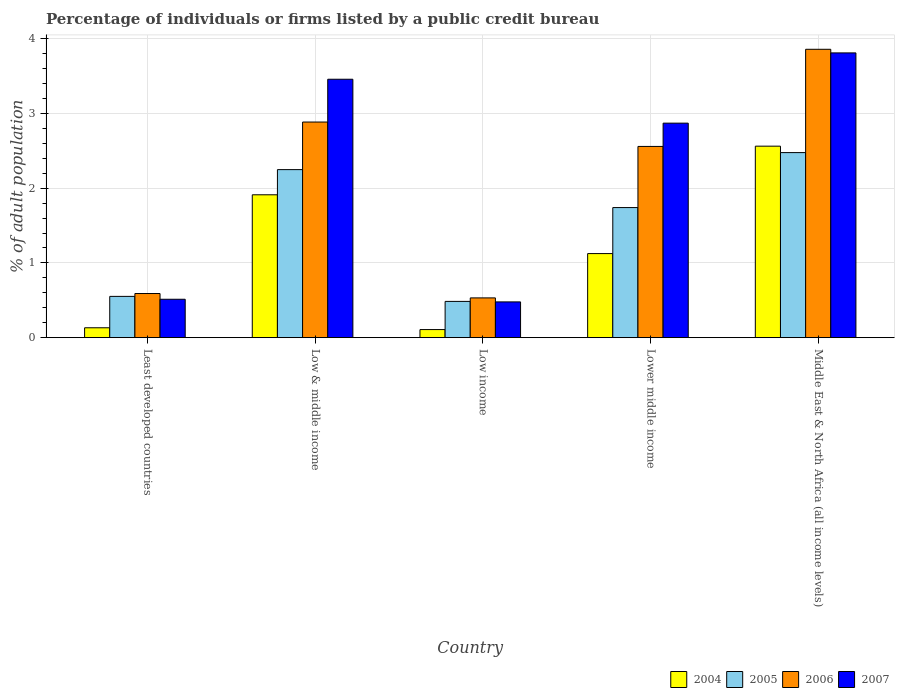How many groups of bars are there?
Your answer should be compact. 5. How many bars are there on the 2nd tick from the right?
Provide a short and direct response. 4. What is the label of the 5th group of bars from the left?
Offer a terse response. Middle East & North Africa (all income levels). In how many cases, is the number of bars for a given country not equal to the number of legend labels?
Provide a succinct answer. 0. What is the percentage of population listed by a public credit bureau in 2007 in Least developed countries?
Ensure brevity in your answer.  0.51. Across all countries, what is the maximum percentage of population listed by a public credit bureau in 2004?
Your answer should be very brief. 2.56. Across all countries, what is the minimum percentage of population listed by a public credit bureau in 2005?
Offer a terse response. 0.49. In which country was the percentage of population listed by a public credit bureau in 2007 maximum?
Offer a very short reply. Middle East & North Africa (all income levels). What is the total percentage of population listed by a public credit bureau in 2006 in the graph?
Offer a very short reply. 10.43. What is the difference between the percentage of population listed by a public credit bureau in 2006 in Least developed countries and that in Low income?
Your response must be concise. 0.06. What is the difference between the percentage of population listed by a public credit bureau in 2007 in Low & middle income and the percentage of population listed by a public credit bureau in 2006 in Low income?
Make the answer very short. 2.93. What is the average percentage of population listed by a public credit bureau in 2004 per country?
Provide a short and direct response. 1.17. What is the difference between the percentage of population listed by a public credit bureau of/in 2004 and percentage of population listed by a public credit bureau of/in 2006 in Low & middle income?
Offer a very short reply. -0.97. In how many countries, is the percentage of population listed by a public credit bureau in 2005 greater than 0.2 %?
Offer a very short reply. 5. What is the ratio of the percentage of population listed by a public credit bureau in 2005 in Least developed countries to that in Lower middle income?
Make the answer very short. 0.32. What is the difference between the highest and the second highest percentage of population listed by a public credit bureau in 2004?
Give a very brief answer. -0.65. What is the difference between the highest and the lowest percentage of population listed by a public credit bureau in 2006?
Make the answer very short. 3.33. In how many countries, is the percentage of population listed by a public credit bureau in 2004 greater than the average percentage of population listed by a public credit bureau in 2004 taken over all countries?
Offer a terse response. 2. Is the sum of the percentage of population listed by a public credit bureau in 2005 in Low & middle income and Middle East & North Africa (all income levels) greater than the maximum percentage of population listed by a public credit bureau in 2007 across all countries?
Your answer should be compact. Yes. Is it the case that in every country, the sum of the percentage of population listed by a public credit bureau in 2007 and percentage of population listed by a public credit bureau in 2004 is greater than the sum of percentage of population listed by a public credit bureau in 2006 and percentage of population listed by a public credit bureau in 2005?
Make the answer very short. No. What does the 4th bar from the right in Low income represents?
Your response must be concise. 2004. Is it the case that in every country, the sum of the percentage of population listed by a public credit bureau in 2006 and percentage of population listed by a public credit bureau in 2004 is greater than the percentage of population listed by a public credit bureau in 2007?
Give a very brief answer. Yes. What is the title of the graph?
Ensure brevity in your answer.  Percentage of individuals or firms listed by a public credit bureau. Does "2007" appear as one of the legend labels in the graph?
Make the answer very short. Yes. What is the label or title of the Y-axis?
Your answer should be very brief. % of adult population. What is the % of adult population of 2004 in Least developed countries?
Ensure brevity in your answer.  0.13. What is the % of adult population in 2005 in Least developed countries?
Offer a very short reply. 0.55. What is the % of adult population in 2006 in Least developed countries?
Your answer should be very brief. 0.59. What is the % of adult population of 2007 in Least developed countries?
Offer a terse response. 0.51. What is the % of adult population of 2004 in Low & middle income?
Keep it short and to the point. 1.91. What is the % of adult population of 2005 in Low & middle income?
Provide a short and direct response. 2.25. What is the % of adult population of 2006 in Low & middle income?
Make the answer very short. 2.89. What is the % of adult population of 2007 in Low & middle income?
Your answer should be very brief. 3.46. What is the % of adult population of 2004 in Low income?
Keep it short and to the point. 0.11. What is the % of adult population in 2005 in Low income?
Offer a very short reply. 0.49. What is the % of adult population in 2006 in Low income?
Your response must be concise. 0.53. What is the % of adult population in 2007 in Low income?
Provide a succinct answer. 0.48. What is the % of adult population of 2004 in Lower middle income?
Your answer should be compact. 1.12. What is the % of adult population of 2005 in Lower middle income?
Ensure brevity in your answer.  1.74. What is the % of adult population of 2006 in Lower middle income?
Offer a terse response. 2.56. What is the % of adult population of 2007 in Lower middle income?
Provide a short and direct response. 2.87. What is the % of adult population in 2004 in Middle East & North Africa (all income levels)?
Your answer should be compact. 2.56. What is the % of adult population in 2005 in Middle East & North Africa (all income levels)?
Make the answer very short. 2.48. What is the % of adult population in 2006 in Middle East & North Africa (all income levels)?
Your answer should be very brief. 3.86. What is the % of adult population in 2007 in Middle East & North Africa (all income levels)?
Keep it short and to the point. 3.81. Across all countries, what is the maximum % of adult population of 2004?
Offer a very short reply. 2.56. Across all countries, what is the maximum % of adult population of 2005?
Provide a short and direct response. 2.48. Across all countries, what is the maximum % of adult population in 2006?
Provide a succinct answer. 3.86. Across all countries, what is the maximum % of adult population in 2007?
Offer a terse response. 3.81. Across all countries, what is the minimum % of adult population of 2004?
Provide a short and direct response. 0.11. Across all countries, what is the minimum % of adult population in 2005?
Offer a very short reply. 0.49. Across all countries, what is the minimum % of adult population of 2006?
Give a very brief answer. 0.53. Across all countries, what is the minimum % of adult population of 2007?
Offer a very short reply. 0.48. What is the total % of adult population in 2004 in the graph?
Make the answer very short. 5.84. What is the total % of adult population in 2005 in the graph?
Provide a short and direct response. 7.5. What is the total % of adult population in 2006 in the graph?
Your response must be concise. 10.43. What is the total % of adult population of 2007 in the graph?
Provide a succinct answer. 11.13. What is the difference between the % of adult population in 2004 in Least developed countries and that in Low & middle income?
Your answer should be compact. -1.78. What is the difference between the % of adult population in 2005 in Least developed countries and that in Low & middle income?
Your response must be concise. -1.7. What is the difference between the % of adult population in 2006 in Least developed countries and that in Low & middle income?
Your answer should be very brief. -2.29. What is the difference between the % of adult population in 2007 in Least developed countries and that in Low & middle income?
Keep it short and to the point. -2.94. What is the difference between the % of adult population of 2004 in Least developed countries and that in Low income?
Keep it short and to the point. 0.02. What is the difference between the % of adult population of 2005 in Least developed countries and that in Low income?
Make the answer very short. 0.07. What is the difference between the % of adult population of 2006 in Least developed countries and that in Low income?
Provide a short and direct response. 0.06. What is the difference between the % of adult population in 2007 in Least developed countries and that in Low income?
Ensure brevity in your answer.  0.04. What is the difference between the % of adult population in 2004 in Least developed countries and that in Lower middle income?
Provide a succinct answer. -0.99. What is the difference between the % of adult population of 2005 in Least developed countries and that in Lower middle income?
Give a very brief answer. -1.19. What is the difference between the % of adult population in 2006 in Least developed countries and that in Lower middle income?
Offer a terse response. -1.97. What is the difference between the % of adult population of 2007 in Least developed countries and that in Lower middle income?
Your answer should be very brief. -2.36. What is the difference between the % of adult population in 2004 in Least developed countries and that in Middle East & North Africa (all income levels)?
Keep it short and to the point. -2.43. What is the difference between the % of adult population of 2005 in Least developed countries and that in Middle East & North Africa (all income levels)?
Offer a very short reply. -1.92. What is the difference between the % of adult population of 2006 in Least developed countries and that in Middle East & North Africa (all income levels)?
Give a very brief answer. -3.27. What is the difference between the % of adult population of 2007 in Least developed countries and that in Middle East & North Africa (all income levels)?
Your answer should be compact. -3.3. What is the difference between the % of adult population in 2004 in Low & middle income and that in Low income?
Keep it short and to the point. 1.8. What is the difference between the % of adult population in 2005 in Low & middle income and that in Low income?
Provide a succinct answer. 1.76. What is the difference between the % of adult population in 2006 in Low & middle income and that in Low income?
Your answer should be compact. 2.35. What is the difference between the % of adult population in 2007 in Low & middle income and that in Low income?
Your answer should be compact. 2.98. What is the difference between the % of adult population in 2004 in Low & middle income and that in Lower middle income?
Your answer should be compact. 0.79. What is the difference between the % of adult population of 2005 in Low & middle income and that in Lower middle income?
Your answer should be compact. 0.51. What is the difference between the % of adult population of 2006 in Low & middle income and that in Lower middle income?
Give a very brief answer. 0.33. What is the difference between the % of adult population in 2007 in Low & middle income and that in Lower middle income?
Your response must be concise. 0.59. What is the difference between the % of adult population of 2004 in Low & middle income and that in Middle East & North Africa (all income levels)?
Offer a terse response. -0.65. What is the difference between the % of adult population in 2005 in Low & middle income and that in Middle East & North Africa (all income levels)?
Ensure brevity in your answer.  -0.23. What is the difference between the % of adult population in 2006 in Low & middle income and that in Middle East & North Africa (all income levels)?
Your answer should be compact. -0.97. What is the difference between the % of adult population of 2007 in Low & middle income and that in Middle East & North Africa (all income levels)?
Offer a terse response. -0.35. What is the difference between the % of adult population in 2004 in Low income and that in Lower middle income?
Make the answer very short. -1.02. What is the difference between the % of adult population in 2005 in Low income and that in Lower middle income?
Provide a succinct answer. -1.26. What is the difference between the % of adult population in 2006 in Low income and that in Lower middle income?
Make the answer very short. -2.03. What is the difference between the % of adult population in 2007 in Low income and that in Lower middle income?
Provide a succinct answer. -2.39. What is the difference between the % of adult population in 2004 in Low income and that in Middle East & North Africa (all income levels)?
Your answer should be compact. -2.45. What is the difference between the % of adult population in 2005 in Low income and that in Middle East & North Africa (all income levels)?
Your response must be concise. -1.99. What is the difference between the % of adult population in 2006 in Low income and that in Middle East & North Africa (all income levels)?
Offer a terse response. -3.33. What is the difference between the % of adult population of 2007 in Low income and that in Middle East & North Africa (all income levels)?
Offer a very short reply. -3.33. What is the difference between the % of adult population of 2004 in Lower middle income and that in Middle East & North Africa (all income levels)?
Provide a short and direct response. -1.44. What is the difference between the % of adult population of 2005 in Lower middle income and that in Middle East & North Africa (all income levels)?
Offer a terse response. -0.74. What is the difference between the % of adult population in 2006 in Lower middle income and that in Middle East & North Africa (all income levels)?
Give a very brief answer. -1.3. What is the difference between the % of adult population in 2007 in Lower middle income and that in Middle East & North Africa (all income levels)?
Give a very brief answer. -0.94. What is the difference between the % of adult population of 2004 in Least developed countries and the % of adult population of 2005 in Low & middle income?
Give a very brief answer. -2.12. What is the difference between the % of adult population of 2004 in Least developed countries and the % of adult population of 2006 in Low & middle income?
Your response must be concise. -2.75. What is the difference between the % of adult population in 2004 in Least developed countries and the % of adult population in 2007 in Low & middle income?
Provide a succinct answer. -3.33. What is the difference between the % of adult population in 2005 in Least developed countries and the % of adult population in 2006 in Low & middle income?
Make the answer very short. -2.33. What is the difference between the % of adult population in 2005 in Least developed countries and the % of adult population in 2007 in Low & middle income?
Offer a very short reply. -2.91. What is the difference between the % of adult population in 2006 in Least developed countries and the % of adult population in 2007 in Low & middle income?
Keep it short and to the point. -2.87. What is the difference between the % of adult population of 2004 in Least developed countries and the % of adult population of 2005 in Low income?
Offer a terse response. -0.35. What is the difference between the % of adult population of 2004 in Least developed countries and the % of adult population of 2006 in Low income?
Offer a very short reply. -0.4. What is the difference between the % of adult population in 2004 in Least developed countries and the % of adult population in 2007 in Low income?
Provide a short and direct response. -0.35. What is the difference between the % of adult population in 2005 in Least developed countries and the % of adult population in 2006 in Low income?
Provide a short and direct response. 0.02. What is the difference between the % of adult population in 2005 in Least developed countries and the % of adult population in 2007 in Low income?
Provide a succinct answer. 0.07. What is the difference between the % of adult population of 2006 in Least developed countries and the % of adult population of 2007 in Low income?
Make the answer very short. 0.11. What is the difference between the % of adult population of 2004 in Least developed countries and the % of adult population of 2005 in Lower middle income?
Your answer should be compact. -1.61. What is the difference between the % of adult population of 2004 in Least developed countries and the % of adult population of 2006 in Lower middle income?
Keep it short and to the point. -2.43. What is the difference between the % of adult population in 2004 in Least developed countries and the % of adult population in 2007 in Lower middle income?
Provide a short and direct response. -2.74. What is the difference between the % of adult population of 2005 in Least developed countries and the % of adult population of 2006 in Lower middle income?
Your response must be concise. -2.01. What is the difference between the % of adult population in 2005 in Least developed countries and the % of adult population in 2007 in Lower middle income?
Keep it short and to the point. -2.32. What is the difference between the % of adult population of 2006 in Least developed countries and the % of adult population of 2007 in Lower middle income?
Make the answer very short. -2.28. What is the difference between the % of adult population in 2004 in Least developed countries and the % of adult population in 2005 in Middle East & North Africa (all income levels)?
Your answer should be very brief. -2.34. What is the difference between the % of adult population of 2004 in Least developed countries and the % of adult population of 2006 in Middle East & North Africa (all income levels)?
Offer a very short reply. -3.73. What is the difference between the % of adult population in 2004 in Least developed countries and the % of adult population in 2007 in Middle East & North Africa (all income levels)?
Give a very brief answer. -3.68. What is the difference between the % of adult population of 2005 in Least developed countries and the % of adult population of 2006 in Middle East & North Africa (all income levels)?
Your answer should be very brief. -3.31. What is the difference between the % of adult population in 2005 in Least developed countries and the % of adult population in 2007 in Middle East & North Africa (all income levels)?
Provide a succinct answer. -3.26. What is the difference between the % of adult population in 2006 in Least developed countries and the % of adult population in 2007 in Middle East & North Africa (all income levels)?
Ensure brevity in your answer.  -3.22. What is the difference between the % of adult population of 2004 in Low & middle income and the % of adult population of 2005 in Low income?
Give a very brief answer. 1.43. What is the difference between the % of adult population of 2004 in Low & middle income and the % of adult population of 2006 in Low income?
Give a very brief answer. 1.38. What is the difference between the % of adult population of 2004 in Low & middle income and the % of adult population of 2007 in Low income?
Make the answer very short. 1.43. What is the difference between the % of adult population of 2005 in Low & middle income and the % of adult population of 2006 in Low income?
Your answer should be compact. 1.72. What is the difference between the % of adult population of 2005 in Low & middle income and the % of adult population of 2007 in Low income?
Give a very brief answer. 1.77. What is the difference between the % of adult population in 2006 in Low & middle income and the % of adult population in 2007 in Low income?
Offer a terse response. 2.41. What is the difference between the % of adult population in 2004 in Low & middle income and the % of adult population in 2005 in Lower middle income?
Your response must be concise. 0.17. What is the difference between the % of adult population in 2004 in Low & middle income and the % of adult population in 2006 in Lower middle income?
Provide a short and direct response. -0.65. What is the difference between the % of adult population in 2004 in Low & middle income and the % of adult population in 2007 in Lower middle income?
Provide a short and direct response. -0.96. What is the difference between the % of adult population in 2005 in Low & middle income and the % of adult population in 2006 in Lower middle income?
Your response must be concise. -0.31. What is the difference between the % of adult population of 2005 in Low & middle income and the % of adult population of 2007 in Lower middle income?
Provide a short and direct response. -0.62. What is the difference between the % of adult population in 2006 in Low & middle income and the % of adult population in 2007 in Lower middle income?
Your answer should be very brief. 0.01. What is the difference between the % of adult population in 2004 in Low & middle income and the % of adult population in 2005 in Middle East & North Africa (all income levels)?
Provide a short and direct response. -0.56. What is the difference between the % of adult population in 2004 in Low & middle income and the % of adult population in 2006 in Middle East & North Africa (all income levels)?
Offer a very short reply. -1.95. What is the difference between the % of adult population in 2004 in Low & middle income and the % of adult population in 2007 in Middle East & North Africa (all income levels)?
Give a very brief answer. -1.9. What is the difference between the % of adult population in 2005 in Low & middle income and the % of adult population in 2006 in Middle East & North Africa (all income levels)?
Ensure brevity in your answer.  -1.61. What is the difference between the % of adult population of 2005 in Low & middle income and the % of adult population of 2007 in Middle East & North Africa (all income levels)?
Provide a succinct answer. -1.56. What is the difference between the % of adult population of 2006 in Low & middle income and the % of adult population of 2007 in Middle East & North Africa (all income levels)?
Keep it short and to the point. -0.93. What is the difference between the % of adult population of 2004 in Low income and the % of adult population of 2005 in Lower middle income?
Provide a short and direct response. -1.63. What is the difference between the % of adult population in 2004 in Low income and the % of adult population in 2006 in Lower middle income?
Ensure brevity in your answer.  -2.45. What is the difference between the % of adult population of 2004 in Low income and the % of adult population of 2007 in Lower middle income?
Offer a terse response. -2.76. What is the difference between the % of adult population in 2005 in Low income and the % of adult population in 2006 in Lower middle income?
Give a very brief answer. -2.07. What is the difference between the % of adult population in 2005 in Low income and the % of adult population in 2007 in Lower middle income?
Your answer should be compact. -2.39. What is the difference between the % of adult population in 2006 in Low income and the % of adult population in 2007 in Lower middle income?
Keep it short and to the point. -2.34. What is the difference between the % of adult population in 2004 in Low income and the % of adult population in 2005 in Middle East & North Africa (all income levels)?
Make the answer very short. -2.37. What is the difference between the % of adult population in 2004 in Low income and the % of adult population in 2006 in Middle East & North Africa (all income levels)?
Make the answer very short. -3.75. What is the difference between the % of adult population of 2004 in Low income and the % of adult population of 2007 in Middle East & North Africa (all income levels)?
Make the answer very short. -3.7. What is the difference between the % of adult population of 2005 in Low income and the % of adult population of 2006 in Middle East & North Africa (all income levels)?
Provide a short and direct response. -3.37. What is the difference between the % of adult population in 2005 in Low income and the % of adult population in 2007 in Middle East & North Africa (all income levels)?
Offer a very short reply. -3.33. What is the difference between the % of adult population of 2006 in Low income and the % of adult population of 2007 in Middle East & North Africa (all income levels)?
Provide a short and direct response. -3.28. What is the difference between the % of adult population in 2004 in Lower middle income and the % of adult population in 2005 in Middle East & North Africa (all income levels)?
Keep it short and to the point. -1.35. What is the difference between the % of adult population of 2004 in Lower middle income and the % of adult population of 2006 in Middle East & North Africa (all income levels)?
Make the answer very short. -2.73. What is the difference between the % of adult population in 2004 in Lower middle income and the % of adult population in 2007 in Middle East & North Africa (all income levels)?
Offer a very short reply. -2.69. What is the difference between the % of adult population in 2005 in Lower middle income and the % of adult population in 2006 in Middle East & North Africa (all income levels)?
Your answer should be compact. -2.12. What is the difference between the % of adult population in 2005 in Lower middle income and the % of adult population in 2007 in Middle East & North Africa (all income levels)?
Give a very brief answer. -2.07. What is the difference between the % of adult population of 2006 in Lower middle income and the % of adult population of 2007 in Middle East & North Africa (all income levels)?
Your answer should be very brief. -1.25. What is the average % of adult population in 2004 per country?
Give a very brief answer. 1.17. What is the average % of adult population in 2005 per country?
Make the answer very short. 1.5. What is the average % of adult population of 2006 per country?
Give a very brief answer. 2.09. What is the average % of adult population in 2007 per country?
Give a very brief answer. 2.23. What is the difference between the % of adult population of 2004 and % of adult population of 2005 in Least developed countries?
Provide a succinct answer. -0.42. What is the difference between the % of adult population of 2004 and % of adult population of 2006 in Least developed countries?
Ensure brevity in your answer.  -0.46. What is the difference between the % of adult population in 2004 and % of adult population in 2007 in Least developed countries?
Give a very brief answer. -0.38. What is the difference between the % of adult population in 2005 and % of adult population in 2006 in Least developed countries?
Make the answer very short. -0.04. What is the difference between the % of adult population in 2005 and % of adult population in 2007 in Least developed countries?
Make the answer very short. 0.04. What is the difference between the % of adult population of 2006 and % of adult population of 2007 in Least developed countries?
Your response must be concise. 0.08. What is the difference between the % of adult population in 2004 and % of adult population in 2005 in Low & middle income?
Your response must be concise. -0.34. What is the difference between the % of adult population in 2004 and % of adult population in 2006 in Low & middle income?
Keep it short and to the point. -0.97. What is the difference between the % of adult population of 2004 and % of adult population of 2007 in Low & middle income?
Give a very brief answer. -1.55. What is the difference between the % of adult population of 2005 and % of adult population of 2006 in Low & middle income?
Ensure brevity in your answer.  -0.64. What is the difference between the % of adult population in 2005 and % of adult population in 2007 in Low & middle income?
Your answer should be compact. -1.21. What is the difference between the % of adult population of 2006 and % of adult population of 2007 in Low & middle income?
Your response must be concise. -0.57. What is the difference between the % of adult population of 2004 and % of adult population of 2005 in Low income?
Offer a terse response. -0.38. What is the difference between the % of adult population of 2004 and % of adult population of 2006 in Low income?
Ensure brevity in your answer.  -0.42. What is the difference between the % of adult population of 2004 and % of adult population of 2007 in Low income?
Give a very brief answer. -0.37. What is the difference between the % of adult population in 2005 and % of adult population in 2006 in Low income?
Ensure brevity in your answer.  -0.05. What is the difference between the % of adult population in 2005 and % of adult population in 2007 in Low income?
Offer a very short reply. 0.01. What is the difference between the % of adult population in 2006 and % of adult population in 2007 in Low income?
Offer a very short reply. 0.05. What is the difference between the % of adult population of 2004 and % of adult population of 2005 in Lower middle income?
Your response must be concise. -0.62. What is the difference between the % of adult population in 2004 and % of adult population in 2006 in Lower middle income?
Your answer should be very brief. -1.43. What is the difference between the % of adult population of 2004 and % of adult population of 2007 in Lower middle income?
Ensure brevity in your answer.  -1.75. What is the difference between the % of adult population in 2005 and % of adult population in 2006 in Lower middle income?
Offer a terse response. -0.82. What is the difference between the % of adult population of 2005 and % of adult population of 2007 in Lower middle income?
Keep it short and to the point. -1.13. What is the difference between the % of adult population of 2006 and % of adult population of 2007 in Lower middle income?
Offer a terse response. -0.31. What is the difference between the % of adult population of 2004 and % of adult population of 2005 in Middle East & North Africa (all income levels)?
Give a very brief answer. 0.09. What is the difference between the % of adult population in 2004 and % of adult population in 2006 in Middle East & North Africa (all income levels)?
Your response must be concise. -1.3. What is the difference between the % of adult population in 2004 and % of adult population in 2007 in Middle East & North Africa (all income levels)?
Offer a very short reply. -1.25. What is the difference between the % of adult population in 2005 and % of adult population in 2006 in Middle East & North Africa (all income levels)?
Make the answer very short. -1.38. What is the difference between the % of adult population of 2005 and % of adult population of 2007 in Middle East & North Africa (all income levels)?
Provide a succinct answer. -1.33. What is the difference between the % of adult population in 2006 and % of adult population in 2007 in Middle East & North Africa (all income levels)?
Make the answer very short. 0.05. What is the ratio of the % of adult population of 2004 in Least developed countries to that in Low & middle income?
Provide a succinct answer. 0.07. What is the ratio of the % of adult population in 2005 in Least developed countries to that in Low & middle income?
Keep it short and to the point. 0.25. What is the ratio of the % of adult population in 2006 in Least developed countries to that in Low & middle income?
Keep it short and to the point. 0.2. What is the ratio of the % of adult population in 2007 in Least developed countries to that in Low & middle income?
Your answer should be very brief. 0.15. What is the ratio of the % of adult population of 2004 in Least developed countries to that in Low income?
Give a very brief answer. 1.22. What is the ratio of the % of adult population in 2005 in Least developed countries to that in Low income?
Your answer should be compact. 1.14. What is the ratio of the % of adult population in 2006 in Least developed countries to that in Low income?
Make the answer very short. 1.11. What is the ratio of the % of adult population of 2007 in Least developed countries to that in Low income?
Provide a succinct answer. 1.07. What is the ratio of the % of adult population of 2004 in Least developed countries to that in Lower middle income?
Offer a terse response. 0.12. What is the ratio of the % of adult population of 2005 in Least developed countries to that in Lower middle income?
Keep it short and to the point. 0.32. What is the ratio of the % of adult population of 2006 in Least developed countries to that in Lower middle income?
Give a very brief answer. 0.23. What is the ratio of the % of adult population of 2007 in Least developed countries to that in Lower middle income?
Keep it short and to the point. 0.18. What is the ratio of the % of adult population in 2004 in Least developed countries to that in Middle East & North Africa (all income levels)?
Provide a short and direct response. 0.05. What is the ratio of the % of adult population of 2005 in Least developed countries to that in Middle East & North Africa (all income levels)?
Offer a very short reply. 0.22. What is the ratio of the % of adult population of 2006 in Least developed countries to that in Middle East & North Africa (all income levels)?
Provide a short and direct response. 0.15. What is the ratio of the % of adult population of 2007 in Least developed countries to that in Middle East & North Africa (all income levels)?
Your response must be concise. 0.13. What is the ratio of the % of adult population in 2004 in Low & middle income to that in Low income?
Your answer should be very brief. 17.65. What is the ratio of the % of adult population of 2005 in Low & middle income to that in Low income?
Ensure brevity in your answer.  4.63. What is the ratio of the % of adult population in 2006 in Low & middle income to that in Low income?
Provide a succinct answer. 5.42. What is the ratio of the % of adult population of 2007 in Low & middle income to that in Low income?
Give a very brief answer. 7.23. What is the ratio of the % of adult population of 2004 in Low & middle income to that in Lower middle income?
Offer a terse response. 1.7. What is the ratio of the % of adult population of 2005 in Low & middle income to that in Lower middle income?
Provide a short and direct response. 1.29. What is the ratio of the % of adult population of 2006 in Low & middle income to that in Lower middle income?
Give a very brief answer. 1.13. What is the ratio of the % of adult population in 2007 in Low & middle income to that in Lower middle income?
Your answer should be very brief. 1.2. What is the ratio of the % of adult population of 2004 in Low & middle income to that in Middle East & North Africa (all income levels)?
Provide a short and direct response. 0.75. What is the ratio of the % of adult population of 2005 in Low & middle income to that in Middle East & North Africa (all income levels)?
Your response must be concise. 0.91. What is the ratio of the % of adult population in 2006 in Low & middle income to that in Middle East & North Africa (all income levels)?
Give a very brief answer. 0.75. What is the ratio of the % of adult population in 2007 in Low & middle income to that in Middle East & North Africa (all income levels)?
Offer a terse response. 0.91. What is the ratio of the % of adult population in 2004 in Low income to that in Lower middle income?
Give a very brief answer. 0.1. What is the ratio of the % of adult population in 2005 in Low income to that in Lower middle income?
Provide a short and direct response. 0.28. What is the ratio of the % of adult population of 2006 in Low income to that in Lower middle income?
Your answer should be compact. 0.21. What is the ratio of the % of adult population in 2004 in Low income to that in Middle East & North Africa (all income levels)?
Keep it short and to the point. 0.04. What is the ratio of the % of adult population in 2005 in Low income to that in Middle East & North Africa (all income levels)?
Keep it short and to the point. 0.2. What is the ratio of the % of adult population in 2006 in Low income to that in Middle East & North Africa (all income levels)?
Your response must be concise. 0.14. What is the ratio of the % of adult population in 2007 in Low income to that in Middle East & North Africa (all income levels)?
Your response must be concise. 0.13. What is the ratio of the % of adult population of 2004 in Lower middle income to that in Middle East & North Africa (all income levels)?
Provide a short and direct response. 0.44. What is the ratio of the % of adult population of 2005 in Lower middle income to that in Middle East & North Africa (all income levels)?
Your answer should be very brief. 0.7. What is the ratio of the % of adult population of 2006 in Lower middle income to that in Middle East & North Africa (all income levels)?
Give a very brief answer. 0.66. What is the ratio of the % of adult population in 2007 in Lower middle income to that in Middle East & North Africa (all income levels)?
Provide a short and direct response. 0.75. What is the difference between the highest and the second highest % of adult population of 2004?
Ensure brevity in your answer.  0.65. What is the difference between the highest and the second highest % of adult population of 2005?
Ensure brevity in your answer.  0.23. What is the difference between the highest and the second highest % of adult population of 2006?
Keep it short and to the point. 0.97. What is the difference between the highest and the second highest % of adult population of 2007?
Give a very brief answer. 0.35. What is the difference between the highest and the lowest % of adult population of 2004?
Offer a terse response. 2.45. What is the difference between the highest and the lowest % of adult population in 2005?
Keep it short and to the point. 1.99. What is the difference between the highest and the lowest % of adult population in 2006?
Keep it short and to the point. 3.33. What is the difference between the highest and the lowest % of adult population in 2007?
Provide a succinct answer. 3.33. 